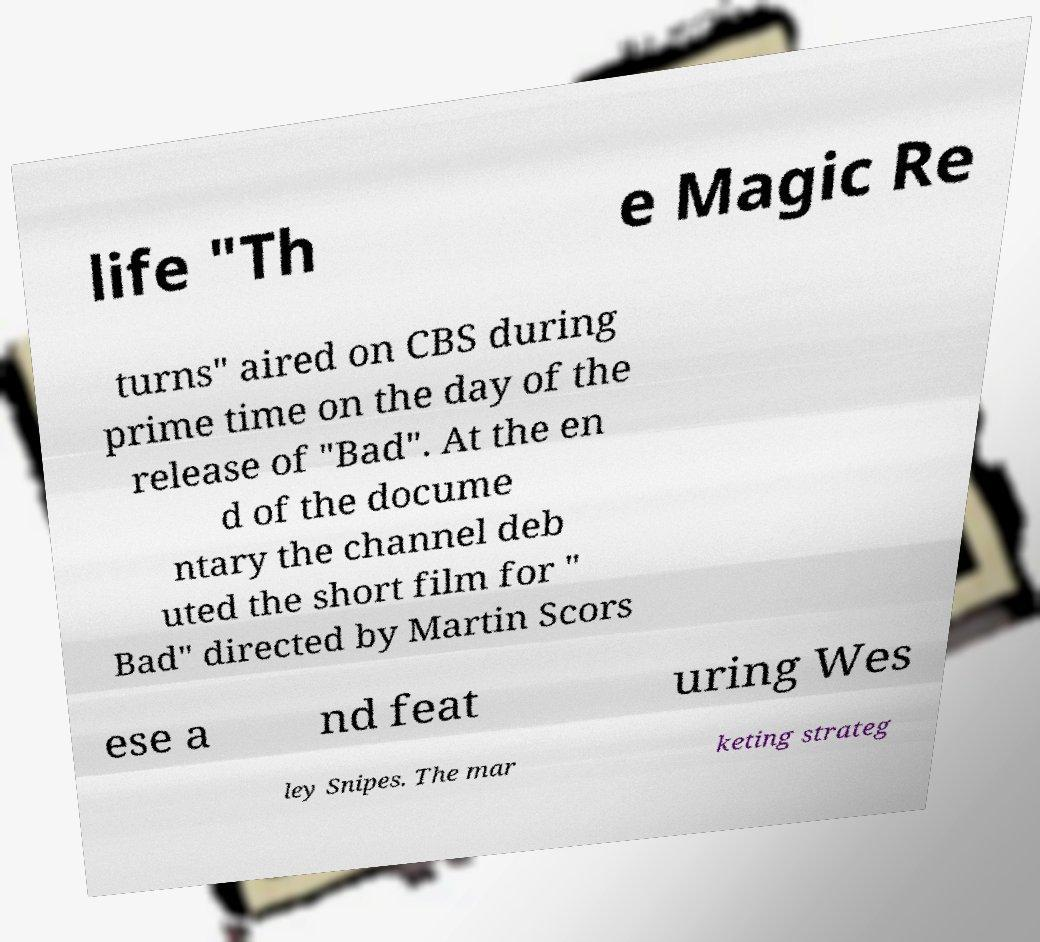What messages or text are displayed in this image? I need them in a readable, typed format. life "Th e Magic Re turns" aired on CBS during prime time on the day of the release of "Bad". At the en d of the docume ntary the channel deb uted the short film for " Bad" directed by Martin Scors ese a nd feat uring Wes ley Snipes. The mar keting strateg 